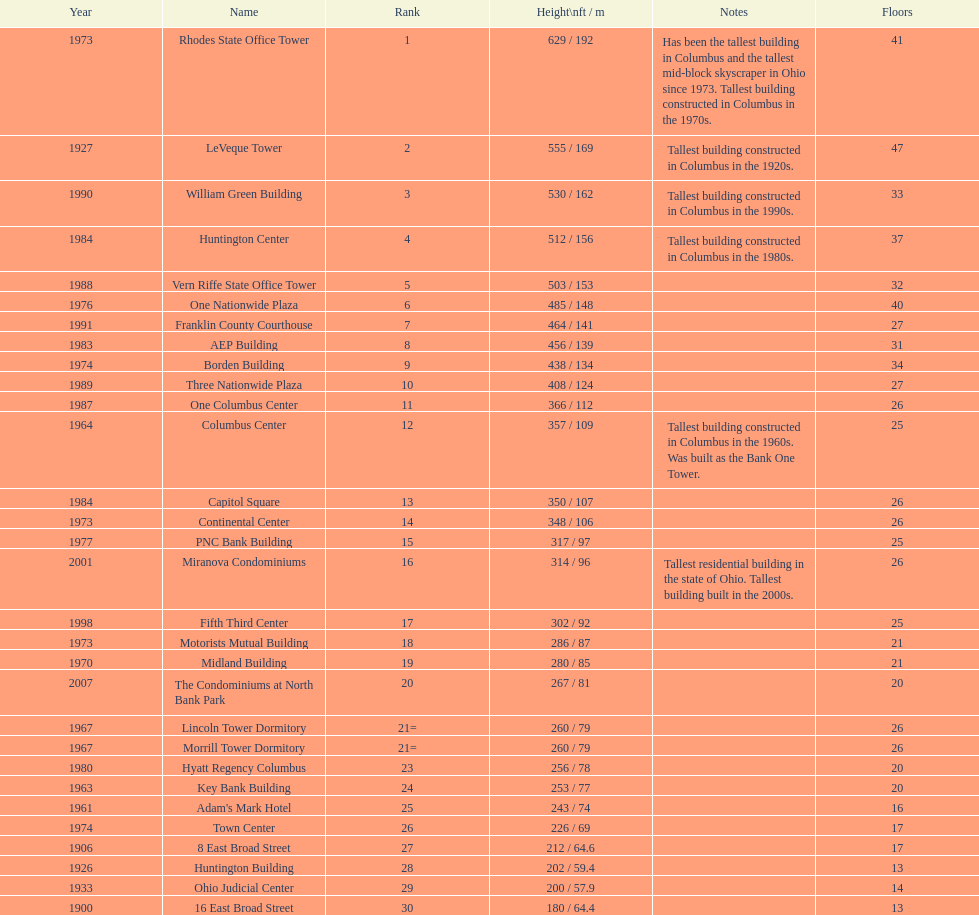What is the number of buildings under 200 ft? 1. 